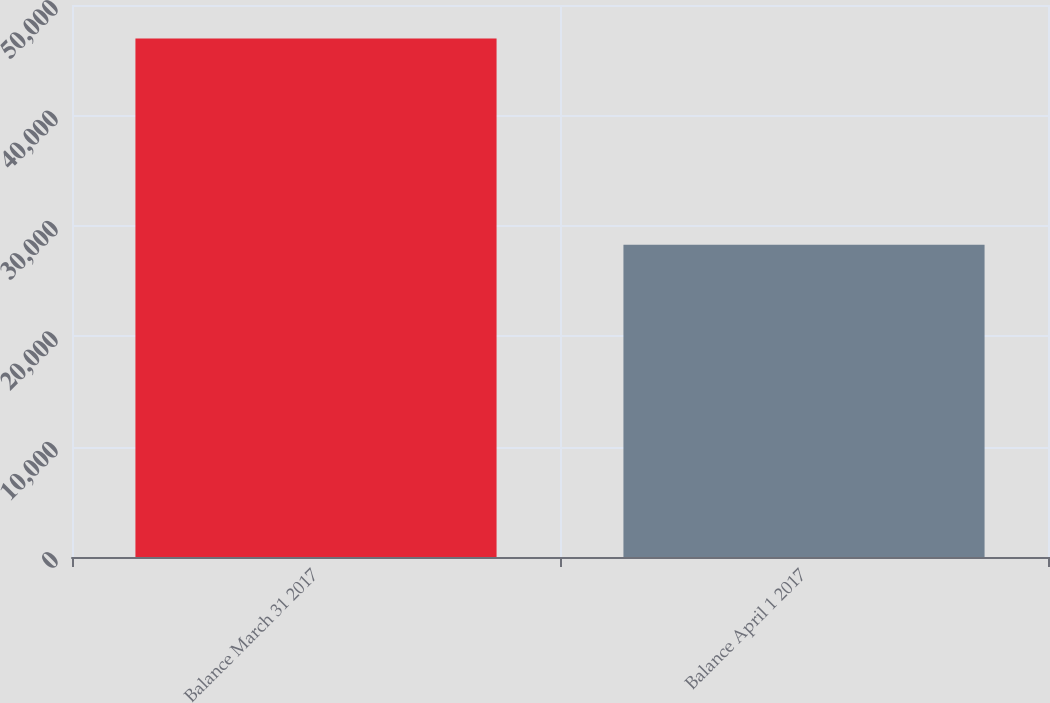<chart> <loc_0><loc_0><loc_500><loc_500><bar_chart><fcel>Balance March 31 2017<fcel>Balance April 1 2017<nl><fcel>46959<fcel>28287<nl></chart> 